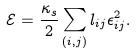Convert formula to latex. <formula><loc_0><loc_0><loc_500><loc_500>\mathcal { E } = \frac { \kappa _ { s } } { 2 } \sum _ { ( i , j ) } l _ { i j } \epsilon _ { i j } ^ { 2 } .</formula> 